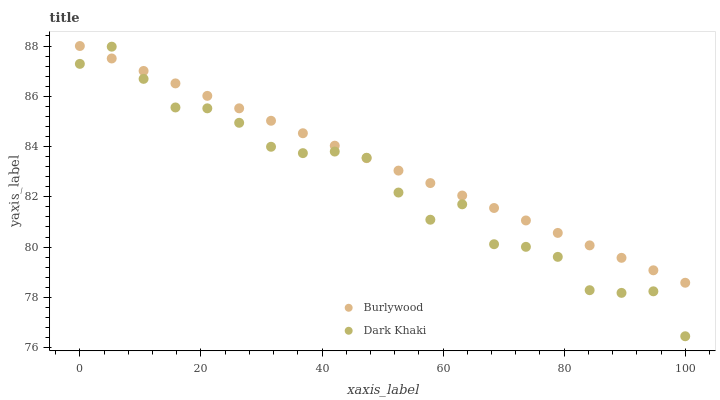Does Dark Khaki have the minimum area under the curve?
Answer yes or no. Yes. Does Burlywood have the maximum area under the curve?
Answer yes or no. Yes. Does Dark Khaki have the maximum area under the curve?
Answer yes or no. No. Is Burlywood the smoothest?
Answer yes or no. Yes. Is Dark Khaki the roughest?
Answer yes or no. Yes. Is Dark Khaki the smoothest?
Answer yes or no. No. Does Dark Khaki have the lowest value?
Answer yes or no. Yes. Does Burlywood have the highest value?
Answer yes or no. Yes. Does Dark Khaki have the highest value?
Answer yes or no. No. Does Burlywood intersect Dark Khaki?
Answer yes or no. Yes. Is Burlywood less than Dark Khaki?
Answer yes or no. No. Is Burlywood greater than Dark Khaki?
Answer yes or no. No. 